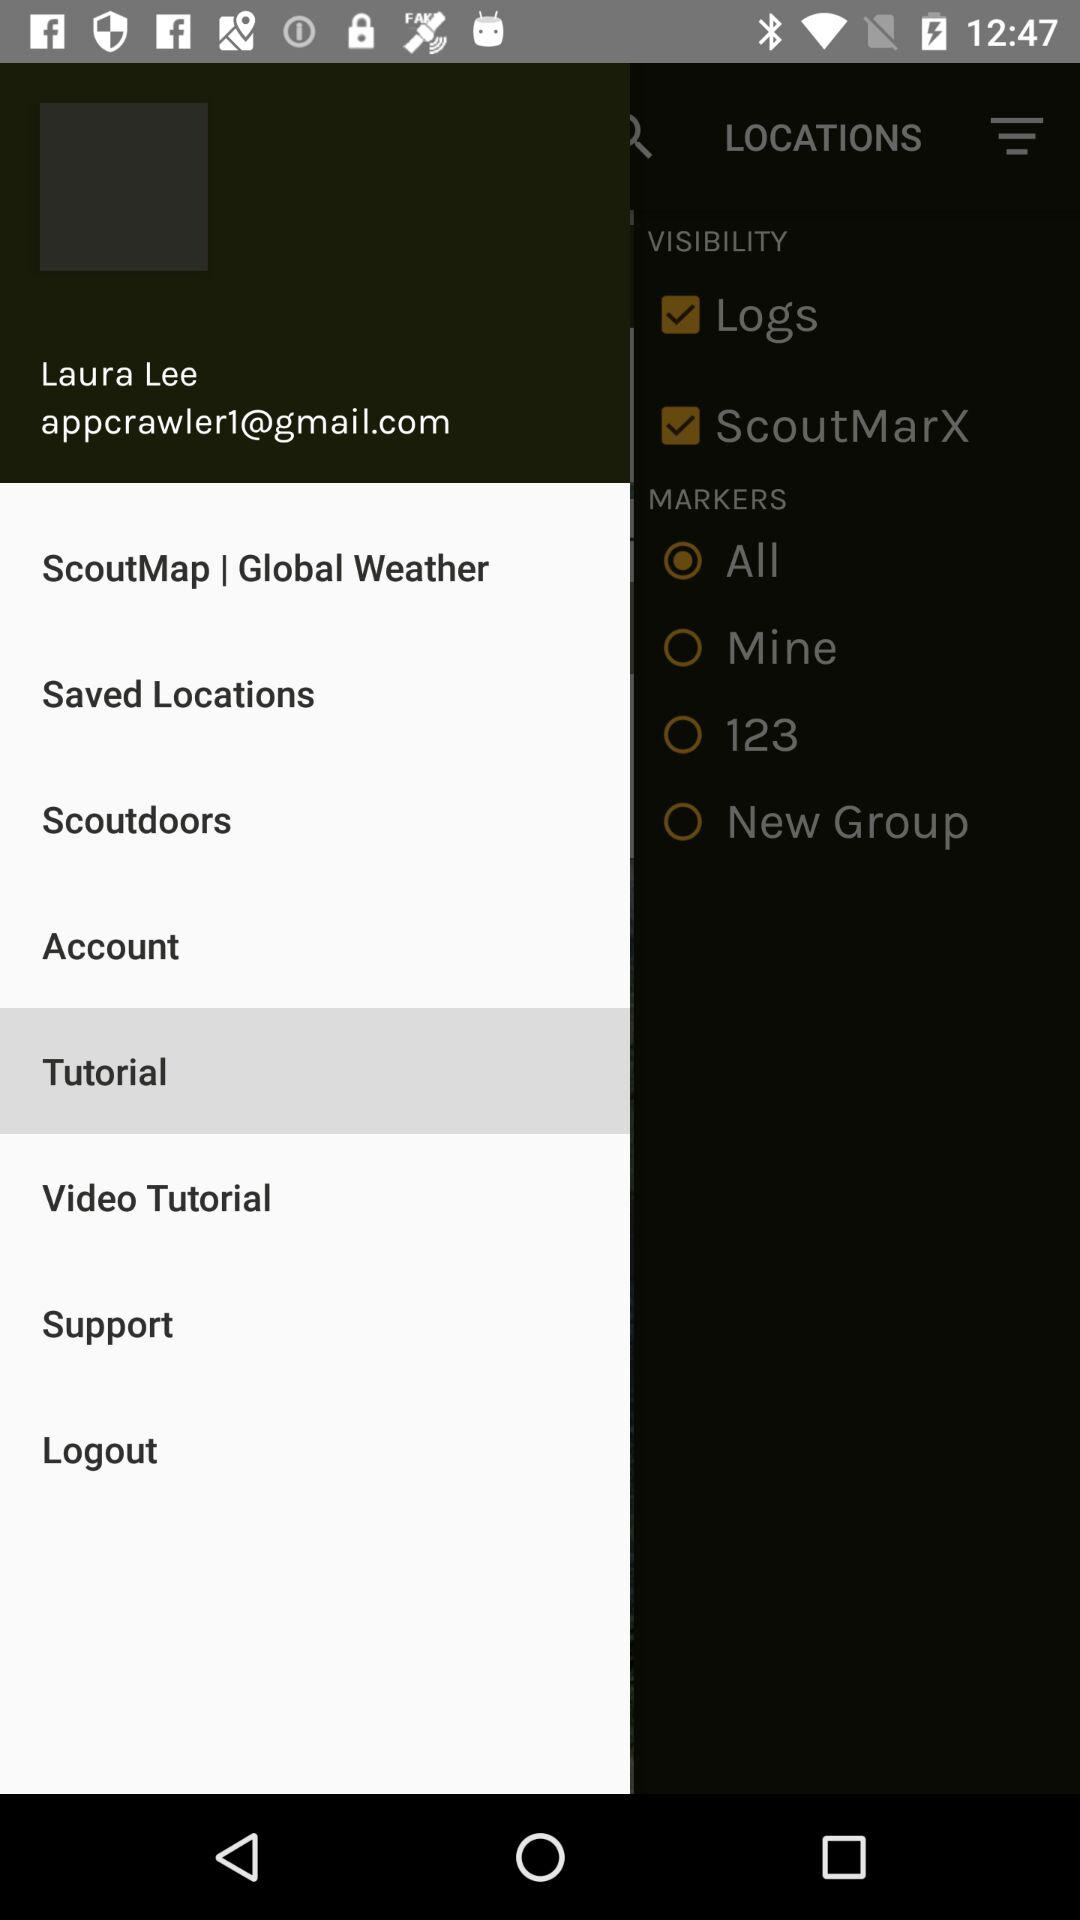What is the selected option? The selected option is "Tutorial". 